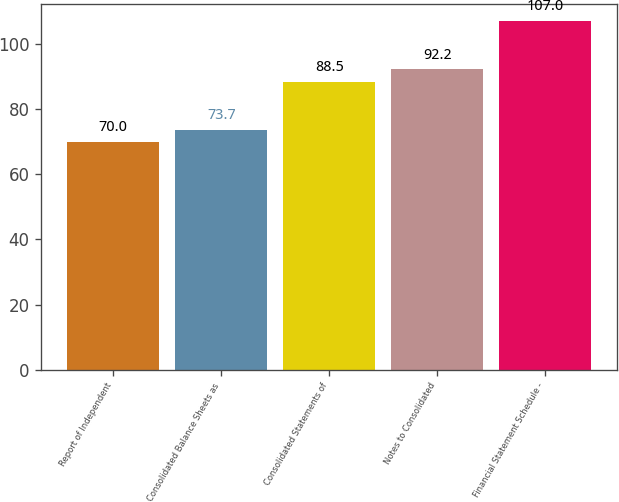Convert chart to OTSL. <chart><loc_0><loc_0><loc_500><loc_500><bar_chart><fcel>Report of Independent<fcel>Consolidated Balance Sheets as<fcel>Consolidated Statements of<fcel>Notes to Consolidated<fcel>Financial Statement Schedule -<nl><fcel>70<fcel>73.7<fcel>88.5<fcel>92.2<fcel>107<nl></chart> 